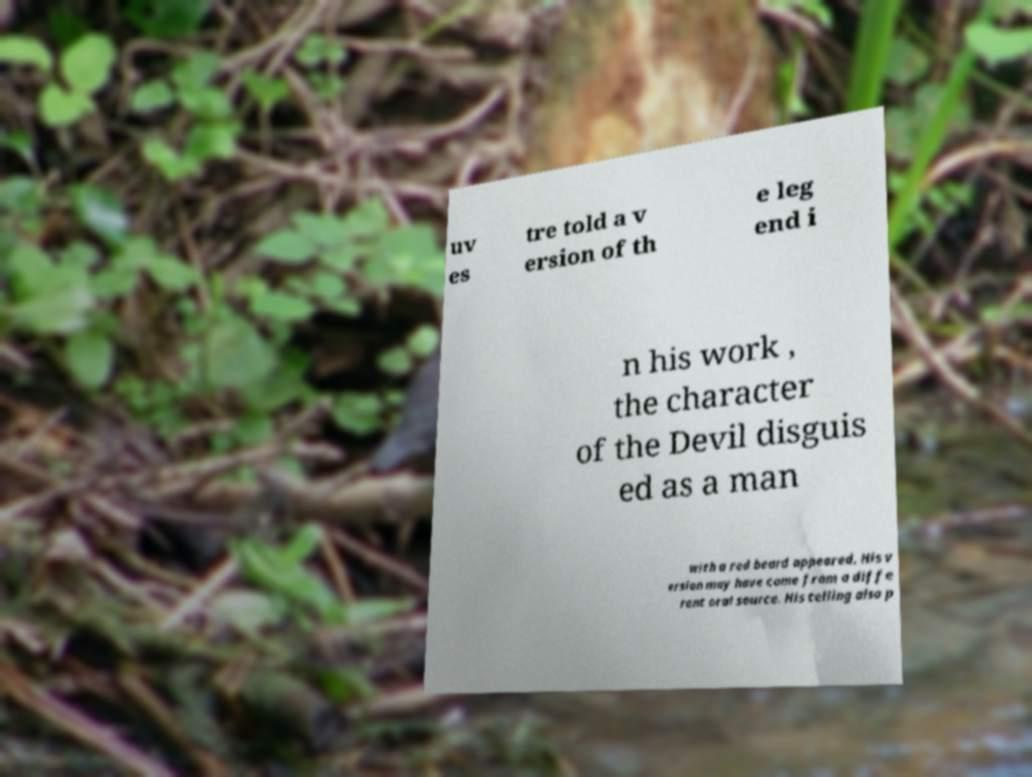What messages or text are displayed in this image? I need them in a readable, typed format. uv es tre told a v ersion of th e leg end i n his work , the character of the Devil disguis ed as a man with a red beard appeared. His v ersion may have come from a diffe rent oral source. His telling also p 